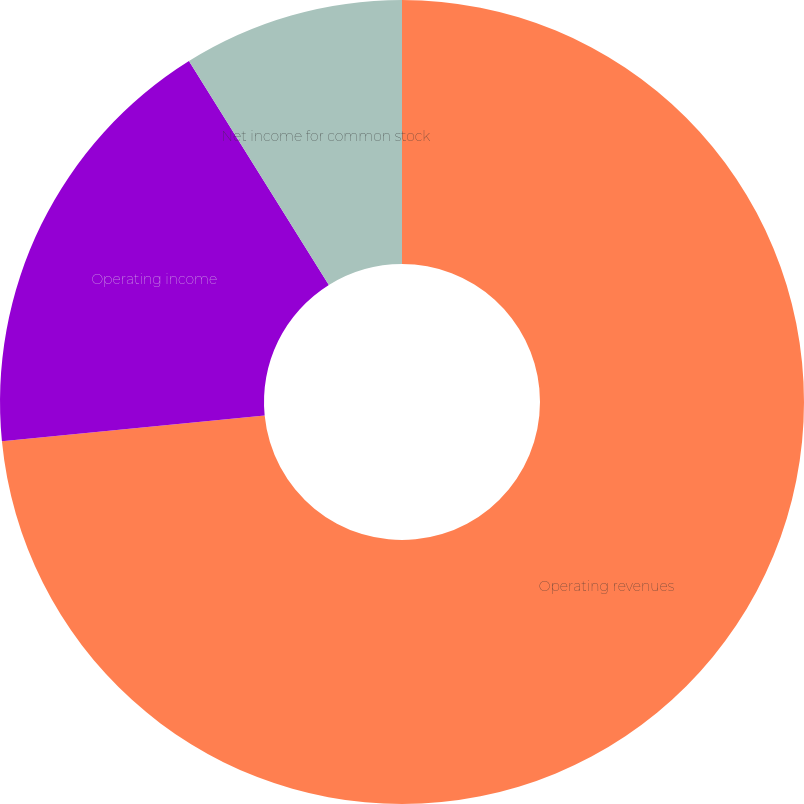Convert chart to OTSL. <chart><loc_0><loc_0><loc_500><loc_500><pie_chart><fcel>Operating revenues<fcel>Operating income<fcel>Net income for common stock<nl><fcel>73.44%<fcel>17.67%<fcel>8.89%<nl></chart> 